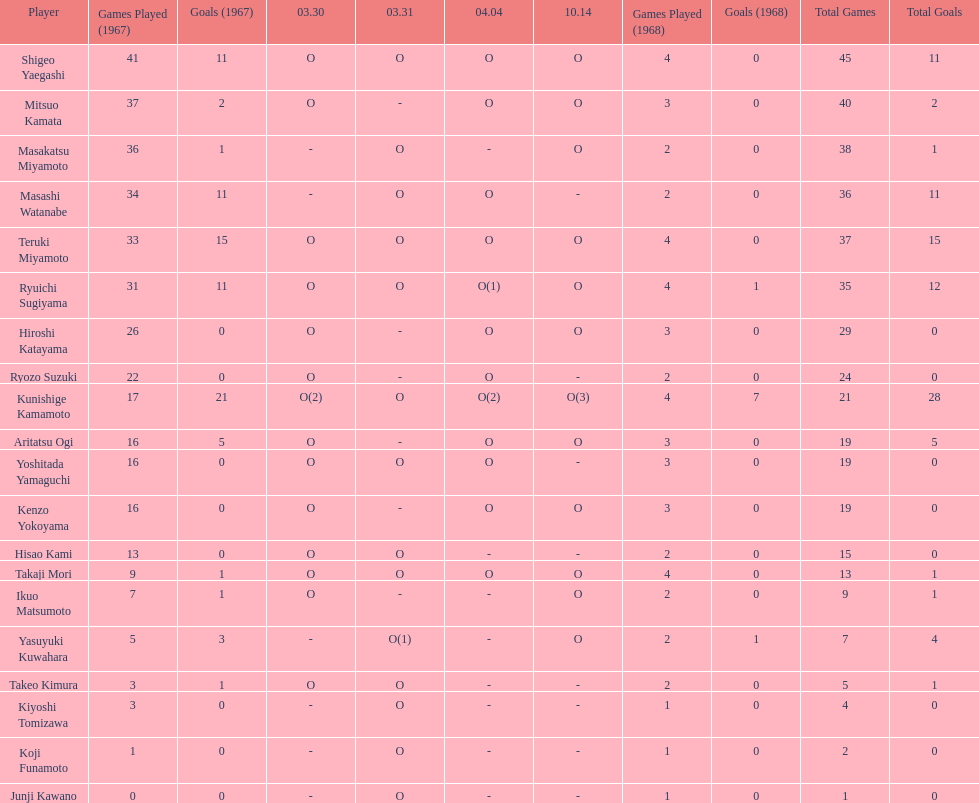How many more total appearances did shigeo yaegashi have than mitsuo kamata? 5. Could you parse the entire table? {'header': ['Player', 'Games Played (1967)', 'Goals (1967)', '03.30', '03.31', '04.04', '10.14', 'Games Played (1968)', 'Goals (1968)', 'Total Games', 'Total Goals'], 'rows': [['Shigeo Yaegashi', '41', '11', 'O', 'O', 'O', 'O', '4', '0', '45', '11'], ['Mitsuo Kamata', '37', '2', 'O', '-', 'O', 'O', '3', '0', '40', '2'], ['Masakatsu Miyamoto', '36', '1', '-', 'O', '-', 'O', '2', '0', '38', '1'], ['Masashi Watanabe', '34', '11', '-', 'O', 'O', '-', '2', '0', '36', '11'], ['Teruki Miyamoto', '33', '15', 'O', 'O', 'O', 'O', '4', '0', '37', '15'], ['Ryuichi Sugiyama', '31', '11', 'O', 'O', 'O(1)', 'O', '4', '1', '35', '12'], ['Hiroshi Katayama', '26', '0', 'O', '-', 'O', 'O', '3', '0', '29', '0'], ['Ryozo Suzuki', '22', '0', 'O', '-', 'O', '-', '2', '0', '24', '0'], ['Kunishige Kamamoto', '17', '21', 'O(2)', 'O', 'O(2)', 'O(3)', '4', '7', '21', '28'], ['Aritatsu Ogi', '16', '5', 'O', '-', 'O', 'O', '3', '0', '19', '5'], ['Yoshitada Yamaguchi', '16', '0', 'O', 'O', 'O', '-', '3', '0', '19', '0'], ['Kenzo Yokoyama', '16', '0', 'O', '-', 'O', 'O', '3', '0', '19', '0'], ['Hisao Kami', '13', '0', 'O', 'O', '-', '-', '2', '0', '15', '0'], ['Takaji Mori', '9', '1', 'O', 'O', 'O', 'O', '4', '0', '13', '1'], ['Ikuo Matsumoto', '7', '1', 'O', '-', '-', 'O', '2', '0', '9', '1'], ['Yasuyuki Kuwahara', '5', '3', '-', 'O(1)', '-', 'O', '2', '1', '7', '4'], ['Takeo Kimura', '3', '1', 'O', 'O', '-', '-', '2', '0', '5', '1'], ['Kiyoshi Tomizawa', '3', '0', '-', 'O', '-', '-', '1', '0', '4', '0'], ['Koji Funamoto', '1', '0', '-', 'O', '-', '-', '1', '0', '2', '0'], ['Junji Kawano', '0', '0', '-', 'O', '-', '-', '1', '0', '1', '0']]} 